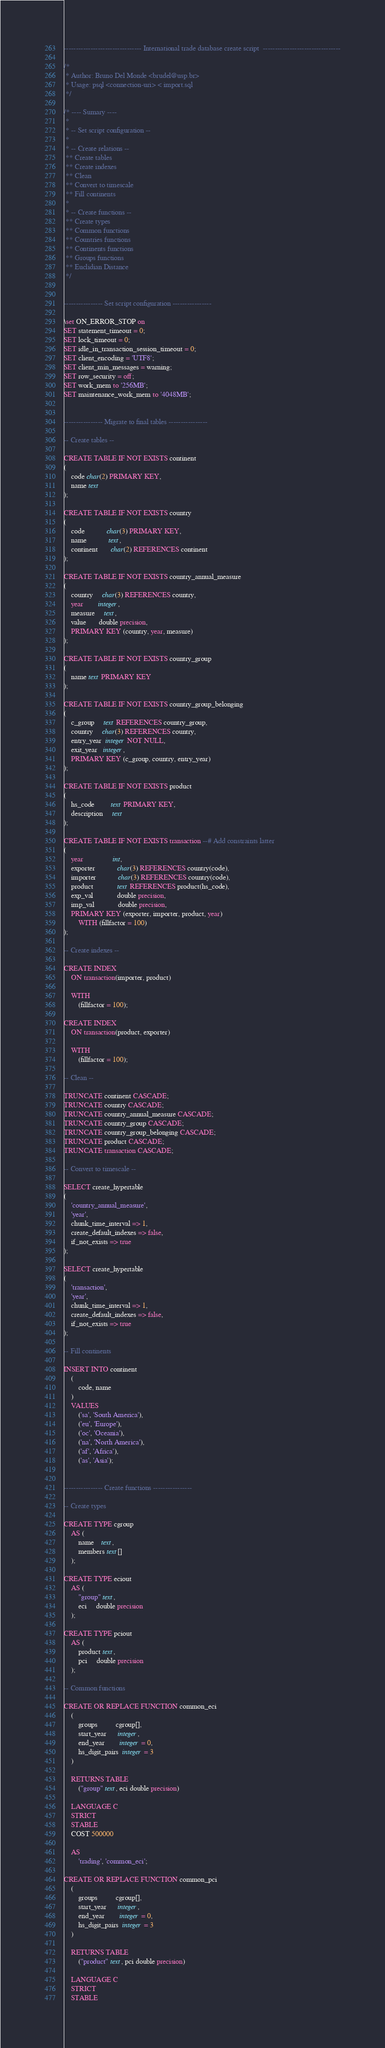Convert code to text. <code><loc_0><loc_0><loc_500><loc_500><_SQL_>
-------------------------------- International trade database create script  --------------------------------

/*
 * Author: Bruno Del Monde <brudel@usp.br>
 * Usage: psql <connection-uri> < import.sql
 */

/* ---- Sumary ----
 *
 * -- Set script configuration --
 *
 * -- Create relations --
 ** Create tables
 ** Create indexes
 ** Clean
 ** Convert to timescale
 ** Fill continents
 *
 * -- Create functions --
 ** Create types
 ** Common functions
 ** Countries functions
 ** Continents functions
 ** Groups functions
 ** Euclidian Distance
 */


---------------- Set script configuration ----------------

\set ON_ERROR_STOP on
SET statement_timeout = 0;
SET lock_timeout = 0;
SET idle_in_transaction_session_timeout = 0;
SET client_encoding = 'UTF8';
SET client_min_messages = warning;
SET row_security = off;
SET work_mem to '256MB';
SET maintenance_work_mem to '4048MB';


---------------- Migrate to final tables ----------------

-- Create tables --

CREATE TABLE IF NOT EXISTS continent
(
    code char(2) PRIMARY KEY,
    name text
);

CREATE TABLE IF NOT EXISTS country
(
    code            char(3) PRIMARY KEY,
    name            text,
    continent       char(2) REFERENCES continent
);

CREATE TABLE IF NOT EXISTS country_annual_measure
(
    country     char(3) REFERENCES country,
    year        integer,
    measure     text,
    value       double precision,
    PRIMARY KEY (country, year, measure)
);

CREATE TABLE IF NOT EXISTS country_group 
(
    name text PRIMARY KEY
);

CREATE TABLE IF NOT EXISTS country_group_belonging
(
    c_group     text REFERENCES country_group,
    country     char(3) REFERENCES country,
    entry_year  integer NOT NULL,
    exit_year   integer,
    PRIMARY KEY (c_group, country, entry_year)
);

CREATE TABLE IF NOT EXISTS product
(
    hs_code         text PRIMARY KEY,
    description     text
);

CREATE TABLE IF NOT EXISTS transaction --# Add constraints latter
(
    year                int,
    exporter            char(3) REFERENCES country(code),
    importer            char(3) REFERENCES country(code),
    product             text REFERENCES product(hs_code),
    exp_val             double precision,
    imp_val             double precision,
    PRIMARY KEY (exporter, importer, product, year)
        WITH (fillfactor = 100)
);

-- Create indexes --

CREATE INDEX
    ON transaction(importer, product)

    WITH
        (fillfactor = 100);

CREATE INDEX
    ON transaction(product, exporter)

    WITH
        (fillfactor = 100);

-- Clean --

TRUNCATE continent CASCADE;
TRUNCATE country CASCADE;
TRUNCATE country_annual_measure CASCADE;
TRUNCATE country_group CASCADE;
TRUNCATE country_group_belonging CASCADE;
TRUNCATE product CASCADE;
TRUNCATE transaction CASCADE;

-- Convert to timescale --

SELECT create_hypertable
(
    'country_annual_measure',
    'year',
    chunk_time_interval => 1,
    create_default_indexes => false,
    if_not_exists => true
);

SELECT create_hypertable
(
    'transaction',
    'year',
    chunk_time_interval => 1,
    create_default_indexes => false,
    if_not_exists => true
);

-- Fill continents

INSERT INTO continent
    (
        code, name
    )
    VALUES
        ('sa', 'South America'),
        ('eu', 'Europe'),
        ('oc', 'Oceania'),
        ('na', 'North America'),
        ('af', 'Africa'),
        ('as', 'Asia');


---------------- Create functions ----------------

-- Create types

CREATE TYPE cgroup
    AS (
        name    text,
        members text[]
    );

CREATE TYPE eciout
    AS (
        "group" text,
        eci     double precision
    );

CREATE TYPE pciout
    AS (
        product text,
        pci     double precision
    );

-- Common functions

CREATE OR REPLACE FUNCTION common_eci
    (
        groups          cgroup[],
        start_year      integer,
        end_year        integer = 0,
        hs_digit_pairs  integer = 3
    )

    RETURNS TABLE
        ("group" text, eci double precision)

    LANGUAGE C
    STRICT
    STABLE
    COST 500000

    AS
        'trading', 'common_eci';

CREATE OR REPLACE FUNCTION common_pci
    (
        groups          cgroup[],
        start_year      integer,
        end_year        integer = 0,
        hs_digit_pairs  integer = 3
    )

    RETURNS TABLE
        ("product" text, pci double precision)

    LANGUAGE C
    STRICT
    STABLE</code> 